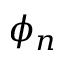Convert formula to latex. <formula><loc_0><loc_0><loc_500><loc_500>\phi _ { n }</formula> 